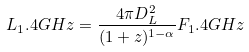Convert formula to latex. <formula><loc_0><loc_0><loc_500><loc_500>L _ { 1 } . 4 G H z = \frac { 4 \pi D _ { L } ^ { 2 } } { ( 1 + z ) ^ { 1 - \alpha } } F _ { 1 } . 4 G H z</formula> 